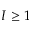<formula> <loc_0><loc_0><loc_500><loc_500>I \geq 1</formula> 